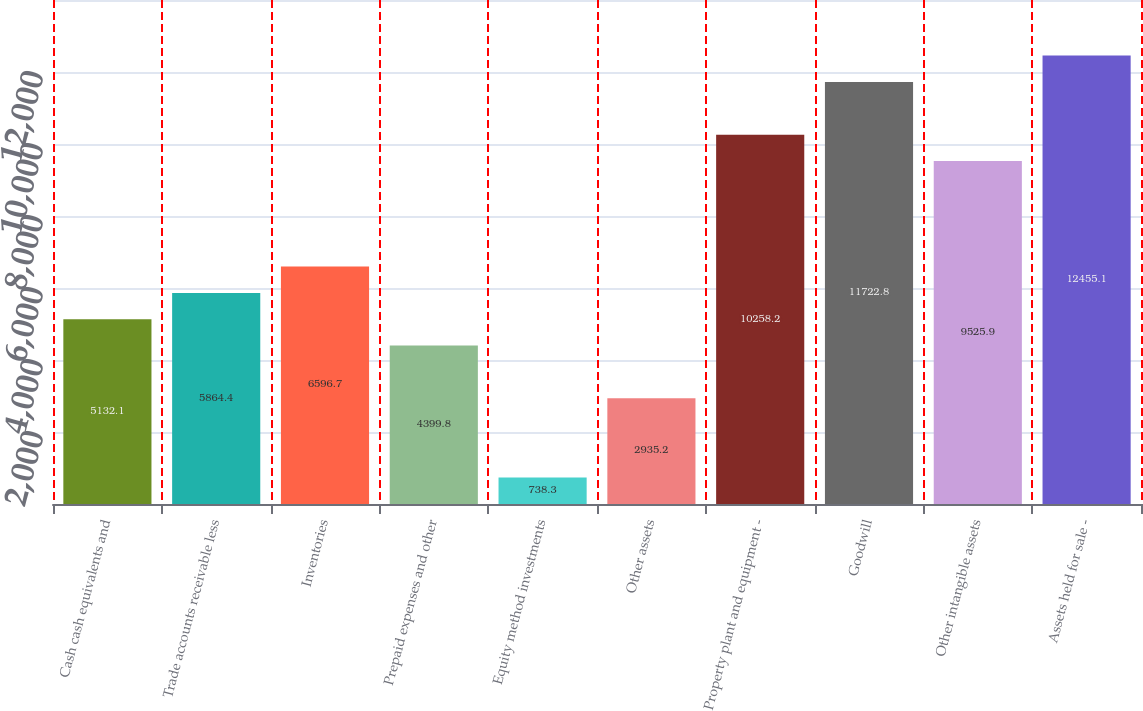Convert chart. <chart><loc_0><loc_0><loc_500><loc_500><bar_chart><fcel>Cash cash equivalents and<fcel>Trade accounts receivable less<fcel>Inventories<fcel>Prepaid expenses and other<fcel>Equity method investments<fcel>Other assets<fcel>Property plant and equipment -<fcel>Goodwill<fcel>Other intangible assets<fcel>Assets held for sale -<nl><fcel>5132.1<fcel>5864.4<fcel>6596.7<fcel>4399.8<fcel>738.3<fcel>2935.2<fcel>10258.2<fcel>11722.8<fcel>9525.9<fcel>12455.1<nl></chart> 